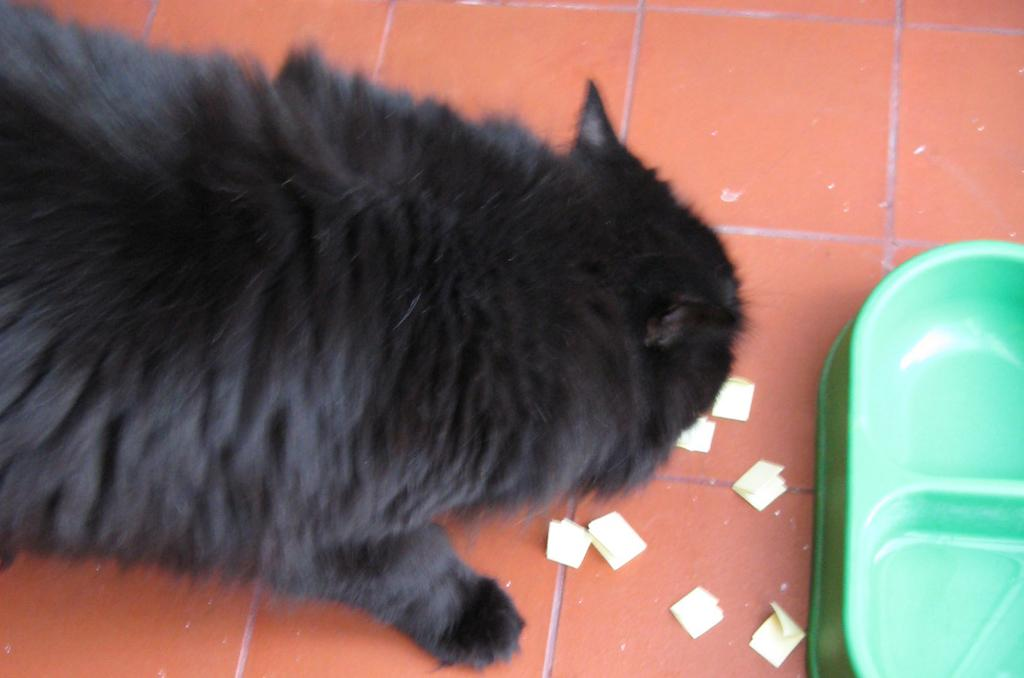What type of animal is on the floor in the image? The animal on the floor in the image is not specified. What else can be seen in the image besides the animal? There are objects that look like papers in the image. Where is the pet bowl located in the image? The pet bowl is on the right side of the image. Can you tell me how many snakes are wrapped around the pet bowl in the image? There are no snakes present in the image; it only features an animal on the floor and objects that look like papers. What type of twig is being used as a vessel in the image? There is no twig or vessel present in the image. 